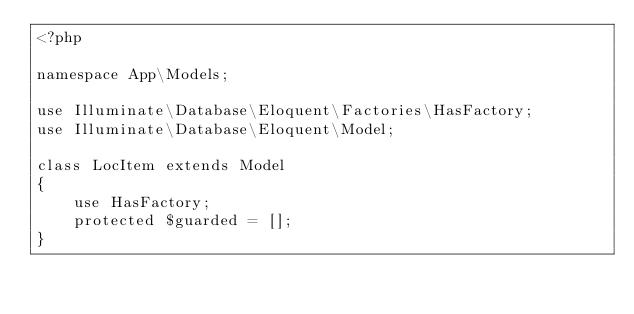Convert code to text. <code><loc_0><loc_0><loc_500><loc_500><_PHP_><?php

namespace App\Models;

use Illuminate\Database\Eloquent\Factories\HasFactory;
use Illuminate\Database\Eloquent\Model;

class LocItem extends Model
{
    use HasFactory;
    protected $guarded = [];
}
</code> 